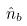<formula> <loc_0><loc_0><loc_500><loc_500>\hat { n } _ { b }</formula> 